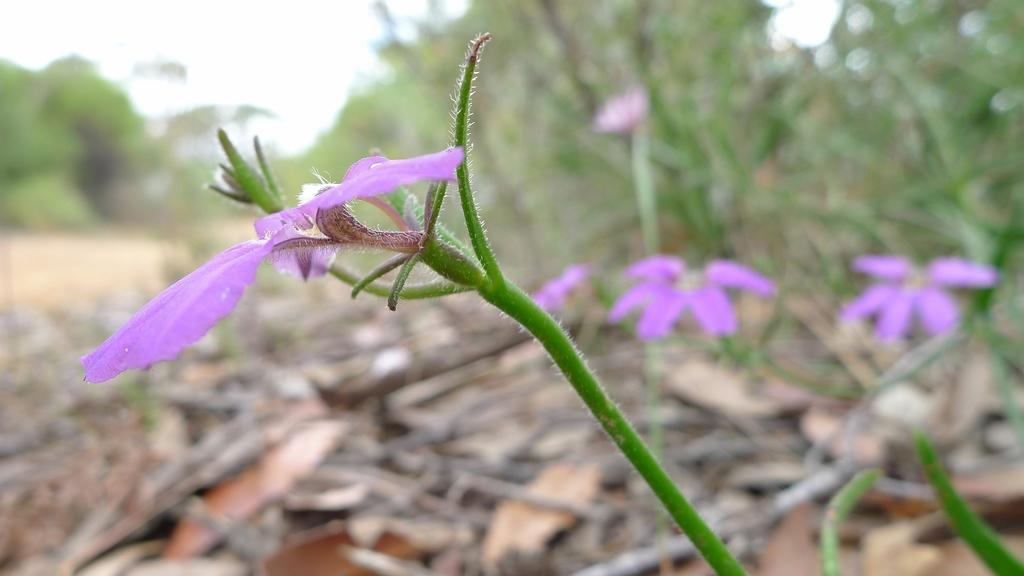What type of plants are in the image? There are flowers in the image. What part of the flowers is visible in the image? There are stems in the image. Can you describe the background of the image? The background of the image is blurry. What type of shoes can be seen in the image? There are no shoes present in the image. Is there a notebook visible in the image? There is no notebook present in the image. 